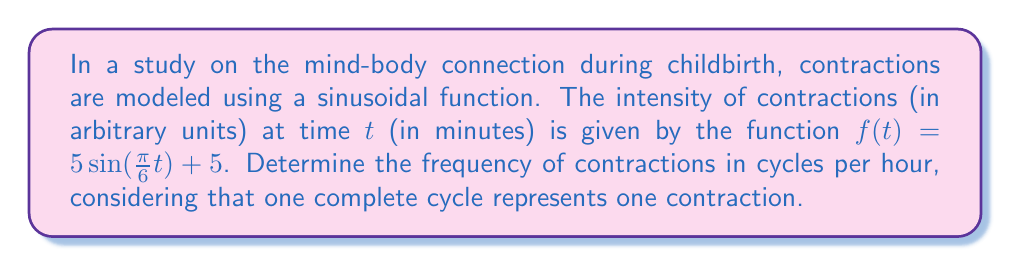Teach me how to tackle this problem. To solve this problem, we'll follow these steps:

1) First, recall that the general form of a sine function is:
   
   $f(t) = A\sin(Bt) + C$

   where $B$ is related to the frequency.

2) In our case, $B = \frac{\pi}{6}$

3) The period of a sine function is given by:
   
   $T = \frac{2\pi}{|B|}$

4) Substituting our value for $B$:
   
   $T = \frac{2\pi}{|\frac{\pi}{6}|} = \frac{2\pi}{\frac{\pi}{6}} = 12$ minutes

5) This means one complete cycle (one contraction) occurs every 12 minutes.

6) To convert this to cycles per hour, we divide 60 minutes by the period:
   
   $\text{Frequency} = \frac{60\text{ minutes}}{12\text{ minutes/cycle}} = 5\text{ cycles/hour}$

Therefore, the frequency of contractions is 5 per hour.
Answer: 5 contractions per hour 